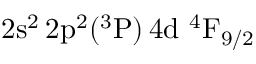Convert formula to latex. <formula><loc_0><loc_0><loc_500><loc_500>2 s ^ { 2 } \, 2 p ^ { 2 } ( ^ { 3 } P ) \, 4 d ^ { 4 } F _ { 9 / 2 }</formula> 